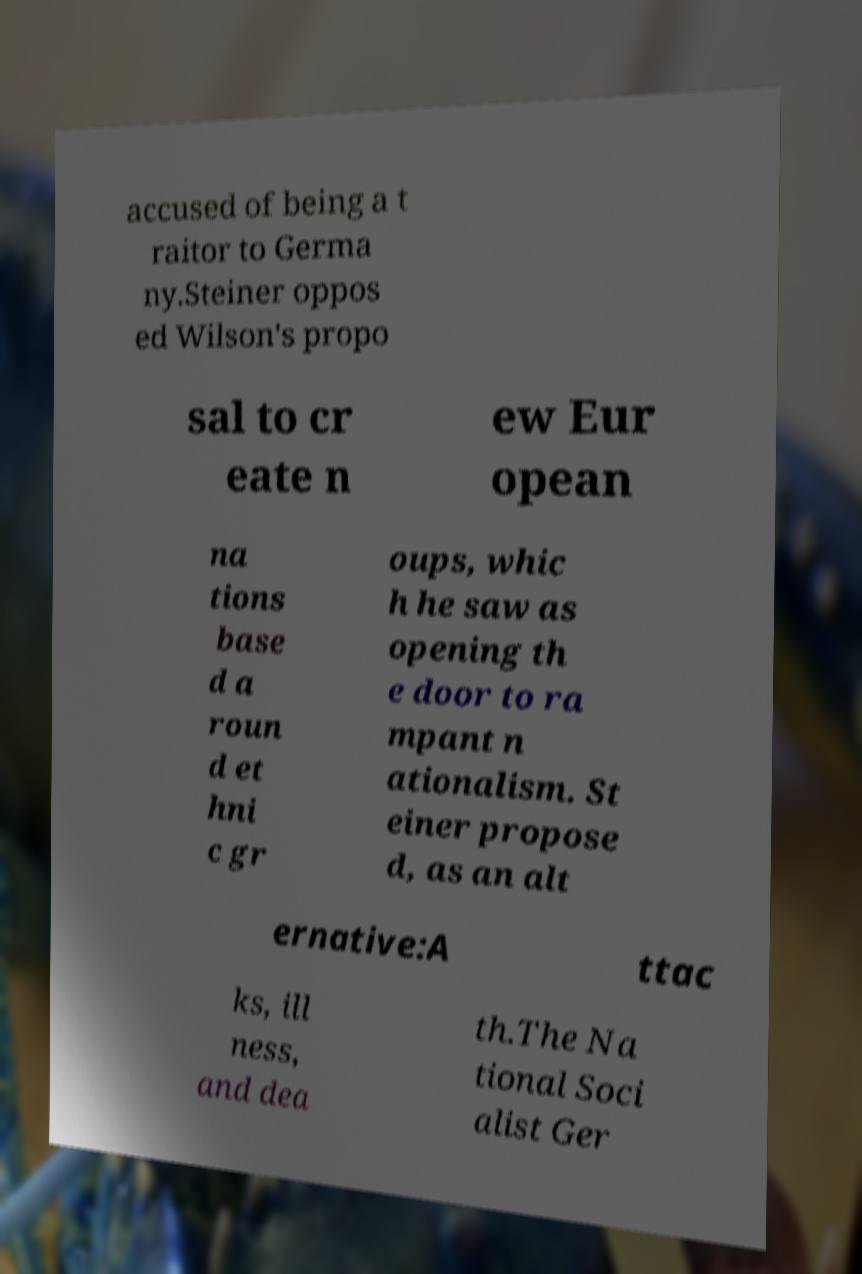Can you accurately transcribe the text from the provided image for me? accused of being a t raitor to Germa ny.Steiner oppos ed Wilson's propo sal to cr eate n ew Eur opean na tions base d a roun d et hni c gr oups, whic h he saw as opening th e door to ra mpant n ationalism. St einer propose d, as an alt ernative:A ttac ks, ill ness, and dea th.The Na tional Soci alist Ger 